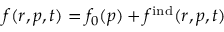<formula> <loc_0><loc_0><loc_500><loc_500>f ( r , p , t ) = f _ { 0 } ( p ) + f ^ { i n d } ( r , p , t )</formula> 